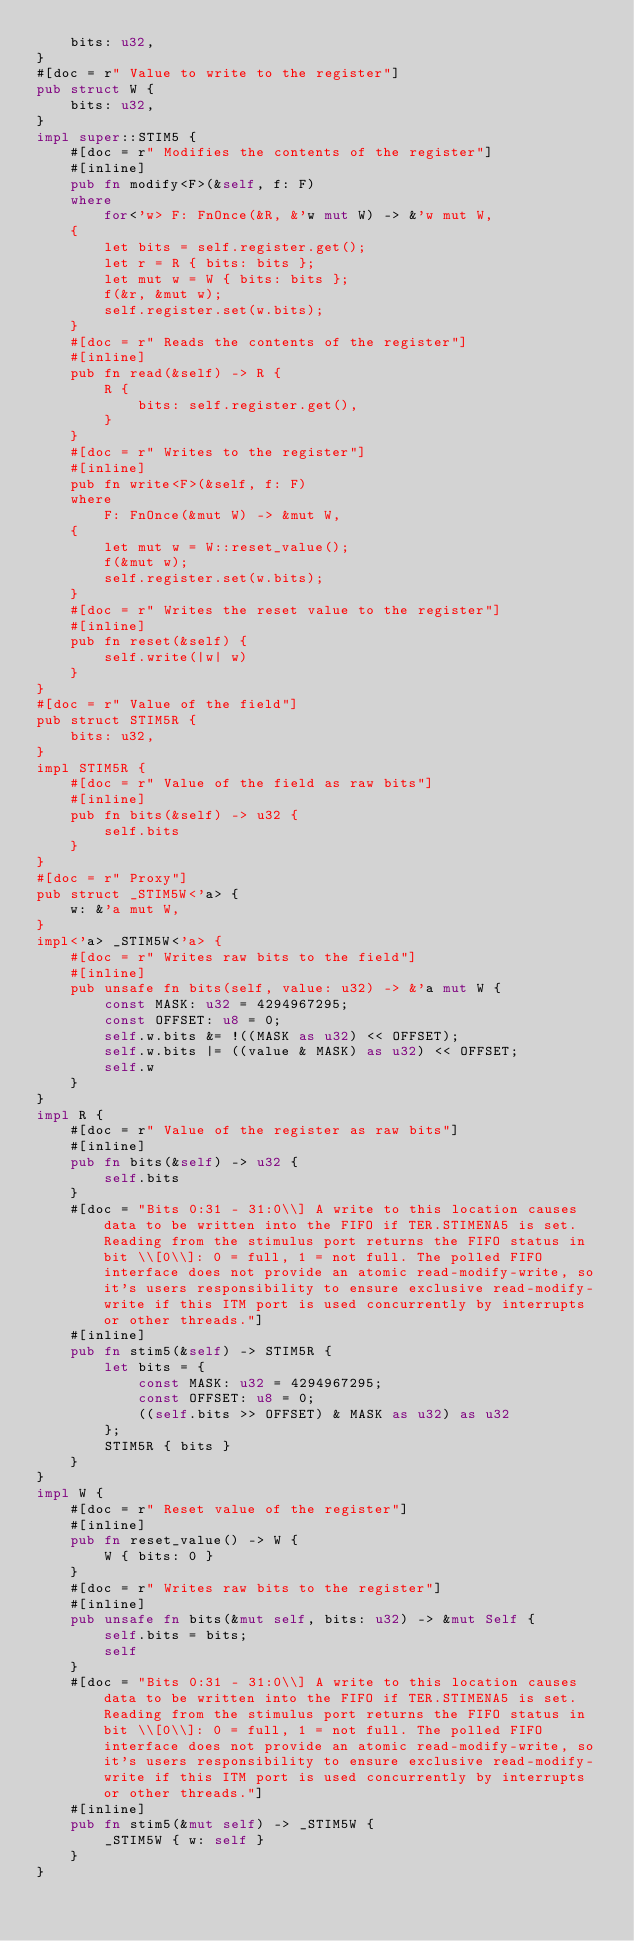Convert code to text. <code><loc_0><loc_0><loc_500><loc_500><_Rust_>    bits: u32,
}
#[doc = r" Value to write to the register"]
pub struct W {
    bits: u32,
}
impl super::STIM5 {
    #[doc = r" Modifies the contents of the register"]
    #[inline]
    pub fn modify<F>(&self, f: F)
    where
        for<'w> F: FnOnce(&R, &'w mut W) -> &'w mut W,
    {
        let bits = self.register.get();
        let r = R { bits: bits };
        let mut w = W { bits: bits };
        f(&r, &mut w);
        self.register.set(w.bits);
    }
    #[doc = r" Reads the contents of the register"]
    #[inline]
    pub fn read(&self) -> R {
        R {
            bits: self.register.get(),
        }
    }
    #[doc = r" Writes to the register"]
    #[inline]
    pub fn write<F>(&self, f: F)
    where
        F: FnOnce(&mut W) -> &mut W,
    {
        let mut w = W::reset_value();
        f(&mut w);
        self.register.set(w.bits);
    }
    #[doc = r" Writes the reset value to the register"]
    #[inline]
    pub fn reset(&self) {
        self.write(|w| w)
    }
}
#[doc = r" Value of the field"]
pub struct STIM5R {
    bits: u32,
}
impl STIM5R {
    #[doc = r" Value of the field as raw bits"]
    #[inline]
    pub fn bits(&self) -> u32 {
        self.bits
    }
}
#[doc = r" Proxy"]
pub struct _STIM5W<'a> {
    w: &'a mut W,
}
impl<'a> _STIM5W<'a> {
    #[doc = r" Writes raw bits to the field"]
    #[inline]
    pub unsafe fn bits(self, value: u32) -> &'a mut W {
        const MASK: u32 = 4294967295;
        const OFFSET: u8 = 0;
        self.w.bits &= !((MASK as u32) << OFFSET);
        self.w.bits |= ((value & MASK) as u32) << OFFSET;
        self.w
    }
}
impl R {
    #[doc = r" Value of the register as raw bits"]
    #[inline]
    pub fn bits(&self) -> u32 {
        self.bits
    }
    #[doc = "Bits 0:31 - 31:0\\] A write to this location causes data to be written into the FIFO if TER.STIMENA5 is set. Reading from the stimulus port returns the FIFO status in bit \\[0\\]: 0 = full, 1 = not full. The polled FIFO interface does not provide an atomic read-modify-write, so it's users responsibility to ensure exclusive read-modify-write if this ITM port is used concurrently by interrupts or other threads."]
    #[inline]
    pub fn stim5(&self) -> STIM5R {
        let bits = {
            const MASK: u32 = 4294967295;
            const OFFSET: u8 = 0;
            ((self.bits >> OFFSET) & MASK as u32) as u32
        };
        STIM5R { bits }
    }
}
impl W {
    #[doc = r" Reset value of the register"]
    #[inline]
    pub fn reset_value() -> W {
        W { bits: 0 }
    }
    #[doc = r" Writes raw bits to the register"]
    #[inline]
    pub unsafe fn bits(&mut self, bits: u32) -> &mut Self {
        self.bits = bits;
        self
    }
    #[doc = "Bits 0:31 - 31:0\\] A write to this location causes data to be written into the FIFO if TER.STIMENA5 is set. Reading from the stimulus port returns the FIFO status in bit \\[0\\]: 0 = full, 1 = not full. The polled FIFO interface does not provide an atomic read-modify-write, so it's users responsibility to ensure exclusive read-modify-write if this ITM port is used concurrently by interrupts or other threads."]
    #[inline]
    pub fn stim5(&mut self) -> _STIM5W {
        _STIM5W { w: self }
    }
}
</code> 